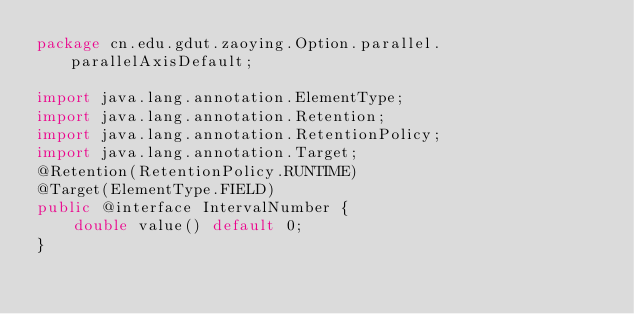<code> <loc_0><loc_0><loc_500><loc_500><_Java_>package cn.edu.gdut.zaoying.Option.parallel.parallelAxisDefault;

import java.lang.annotation.ElementType;
import java.lang.annotation.Retention;
import java.lang.annotation.RetentionPolicy;
import java.lang.annotation.Target;
@Retention(RetentionPolicy.RUNTIME)
@Target(ElementType.FIELD)
public @interface IntervalNumber {
    double value() default 0;
}</code> 